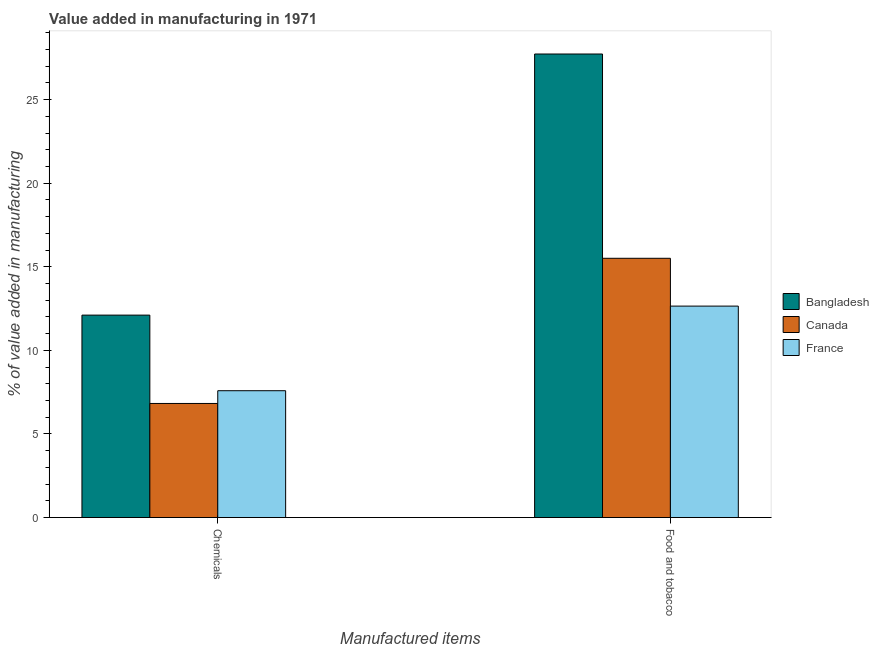Are the number of bars per tick equal to the number of legend labels?
Keep it short and to the point. Yes. What is the label of the 2nd group of bars from the left?
Make the answer very short. Food and tobacco. What is the value added by  manufacturing chemicals in Canada?
Your response must be concise. 6.83. Across all countries, what is the maximum value added by manufacturing food and tobacco?
Your answer should be compact. 27.73. Across all countries, what is the minimum value added by manufacturing food and tobacco?
Make the answer very short. 12.65. In which country was the value added by  manufacturing chemicals maximum?
Your response must be concise. Bangladesh. What is the total value added by  manufacturing chemicals in the graph?
Ensure brevity in your answer.  26.53. What is the difference between the value added by  manufacturing chemicals in Bangladesh and that in Canada?
Your response must be concise. 5.29. What is the difference between the value added by  manufacturing chemicals in Bangladesh and the value added by manufacturing food and tobacco in France?
Provide a short and direct response. -0.54. What is the average value added by manufacturing food and tobacco per country?
Keep it short and to the point. 18.63. What is the difference between the value added by manufacturing food and tobacco and value added by  manufacturing chemicals in Bangladesh?
Provide a succinct answer. 15.62. What is the ratio of the value added by  manufacturing chemicals in France to that in Bangladesh?
Your response must be concise. 0.63. What does the 3rd bar from the left in Food and tobacco represents?
Give a very brief answer. France. What does the 3rd bar from the right in Food and tobacco represents?
Provide a short and direct response. Bangladesh. What is the difference between two consecutive major ticks on the Y-axis?
Provide a short and direct response. 5. Where does the legend appear in the graph?
Offer a terse response. Center right. What is the title of the graph?
Provide a short and direct response. Value added in manufacturing in 1971. What is the label or title of the X-axis?
Keep it short and to the point. Manufactured items. What is the label or title of the Y-axis?
Provide a succinct answer. % of value added in manufacturing. What is the % of value added in manufacturing of Bangladesh in Chemicals?
Your answer should be very brief. 12.11. What is the % of value added in manufacturing in Canada in Chemicals?
Ensure brevity in your answer.  6.83. What is the % of value added in manufacturing of France in Chemicals?
Offer a very short reply. 7.59. What is the % of value added in manufacturing of Bangladesh in Food and tobacco?
Keep it short and to the point. 27.73. What is the % of value added in manufacturing of Canada in Food and tobacco?
Ensure brevity in your answer.  15.51. What is the % of value added in manufacturing in France in Food and tobacco?
Give a very brief answer. 12.65. Across all Manufactured items, what is the maximum % of value added in manufacturing in Bangladesh?
Provide a succinct answer. 27.73. Across all Manufactured items, what is the maximum % of value added in manufacturing in Canada?
Offer a terse response. 15.51. Across all Manufactured items, what is the maximum % of value added in manufacturing of France?
Ensure brevity in your answer.  12.65. Across all Manufactured items, what is the minimum % of value added in manufacturing in Bangladesh?
Offer a very short reply. 12.11. Across all Manufactured items, what is the minimum % of value added in manufacturing in Canada?
Provide a short and direct response. 6.83. Across all Manufactured items, what is the minimum % of value added in manufacturing of France?
Your response must be concise. 7.59. What is the total % of value added in manufacturing of Bangladesh in the graph?
Offer a very short reply. 39.85. What is the total % of value added in manufacturing in Canada in the graph?
Ensure brevity in your answer.  22.34. What is the total % of value added in manufacturing in France in the graph?
Give a very brief answer. 20.24. What is the difference between the % of value added in manufacturing of Bangladesh in Chemicals and that in Food and tobacco?
Give a very brief answer. -15.62. What is the difference between the % of value added in manufacturing of Canada in Chemicals and that in Food and tobacco?
Make the answer very short. -8.69. What is the difference between the % of value added in manufacturing in France in Chemicals and that in Food and tobacco?
Offer a terse response. -5.06. What is the difference between the % of value added in manufacturing in Bangladesh in Chemicals and the % of value added in manufacturing in Canada in Food and tobacco?
Make the answer very short. -3.4. What is the difference between the % of value added in manufacturing in Bangladesh in Chemicals and the % of value added in manufacturing in France in Food and tobacco?
Provide a short and direct response. -0.54. What is the difference between the % of value added in manufacturing of Canada in Chemicals and the % of value added in manufacturing of France in Food and tobacco?
Provide a succinct answer. -5.82. What is the average % of value added in manufacturing of Bangladesh per Manufactured items?
Offer a very short reply. 19.92. What is the average % of value added in manufacturing in Canada per Manufactured items?
Your response must be concise. 11.17. What is the average % of value added in manufacturing in France per Manufactured items?
Offer a terse response. 10.12. What is the difference between the % of value added in manufacturing in Bangladesh and % of value added in manufacturing in Canada in Chemicals?
Your response must be concise. 5.29. What is the difference between the % of value added in manufacturing in Bangladesh and % of value added in manufacturing in France in Chemicals?
Give a very brief answer. 4.52. What is the difference between the % of value added in manufacturing in Canada and % of value added in manufacturing in France in Chemicals?
Give a very brief answer. -0.76. What is the difference between the % of value added in manufacturing of Bangladesh and % of value added in manufacturing of Canada in Food and tobacco?
Your answer should be compact. 12.22. What is the difference between the % of value added in manufacturing in Bangladesh and % of value added in manufacturing in France in Food and tobacco?
Your response must be concise. 15.08. What is the difference between the % of value added in manufacturing in Canada and % of value added in manufacturing in France in Food and tobacco?
Keep it short and to the point. 2.86. What is the ratio of the % of value added in manufacturing in Bangladesh in Chemicals to that in Food and tobacco?
Provide a short and direct response. 0.44. What is the ratio of the % of value added in manufacturing in Canada in Chemicals to that in Food and tobacco?
Provide a succinct answer. 0.44. What is the ratio of the % of value added in manufacturing in France in Chemicals to that in Food and tobacco?
Keep it short and to the point. 0.6. What is the difference between the highest and the second highest % of value added in manufacturing in Bangladesh?
Offer a terse response. 15.62. What is the difference between the highest and the second highest % of value added in manufacturing of Canada?
Offer a very short reply. 8.69. What is the difference between the highest and the second highest % of value added in manufacturing of France?
Your answer should be very brief. 5.06. What is the difference between the highest and the lowest % of value added in manufacturing of Bangladesh?
Keep it short and to the point. 15.62. What is the difference between the highest and the lowest % of value added in manufacturing in Canada?
Your answer should be very brief. 8.69. What is the difference between the highest and the lowest % of value added in manufacturing of France?
Your answer should be very brief. 5.06. 